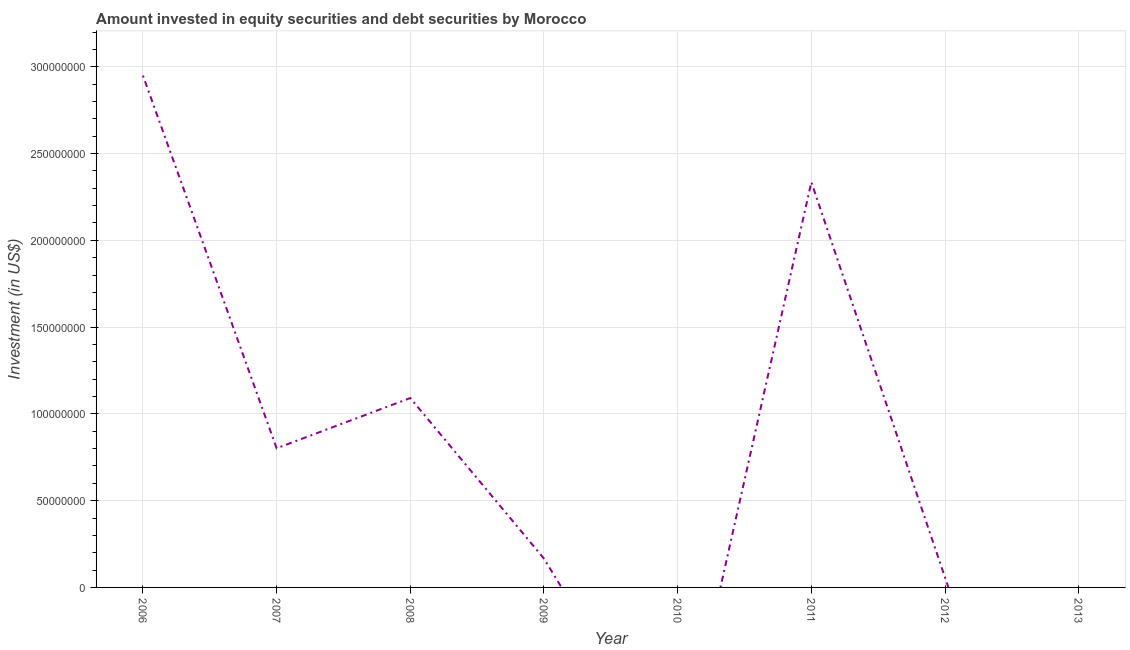What is the portfolio investment in 2008?
Keep it short and to the point. 1.09e+08. Across all years, what is the maximum portfolio investment?
Ensure brevity in your answer.  2.95e+08. Across all years, what is the minimum portfolio investment?
Keep it short and to the point. 0. What is the sum of the portfolio investment?
Make the answer very short. 7.40e+08. What is the difference between the portfolio investment in 2008 and 2009?
Provide a short and direct response. 9.25e+07. What is the average portfolio investment per year?
Keep it short and to the point. 9.25e+07. What is the median portfolio investment?
Keep it short and to the point. 4.84e+07. What is the ratio of the portfolio investment in 2008 to that in 2009?
Your answer should be very brief. 6.58. What is the difference between the highest and the second highest portfolio investment?
Your answer should be compact. 6.14e+07. Is the sum of the portfolio investment in 2008 and 2009 greater than the maximum portfolio investment across all years?
Your response must be concise. No. What is the difference between the highest and the lowest portfolio investment?
Offer a terse response. 2.95e+08. Does the portfolio investment monotonically increase over the years?
Offer a very short reply. No. How many lines are there?
Keep it short and to the point. 1. What is the difference between two consecutive major ticks on the Y-axis?
Give a very brief answer. 5.00e+07. Are the values on the major ticks of Y-axis written in scientific E-notation?
Your answer should be compact. No. Does the graph contain grids?
Provide a short and direct response. Yes. What is the title of the graph?
Ensure brevity in your answer.  Amount invested in equity securities and debt securities by Morocco. What is the label or title of the X-axis?
Provide a short and direct response. Year. What is the label or title of the Y-axis?
Your answer should be compact. Investment (in US$). What is the Investment (in US$) of 2006?
Provide a short and direct response. 2.95e+08. What is the Investment (in US$) of 2007?
Make the answer very short. 8.02e+07. What is the Investment (in US$) in 2008?
Give a very brief answer. 1.09e+08. What is the Investment (in US$) of 2009?
Offer a very short reply. 1.66e+07. What is the Investment (in US$) in 2010?
Provide a short and direct response. 0. What is the Investment (in US$) in 2011?
Provide a short and direct response. 2.34e+08. What is the Investment (in US$) in 2012?
Your response must be concise. 5.72e+06. What is the difference between the Investment (in US$) in 2006 and 2007?
Provide a succinct answer. 2.15e+08. What is the difference between the Investment (in US$) in 2006 and 2008?
Keep it short and to the point. 1.86e+08. What is the difference between the Investment (in US$) in 2006 and 2009?
Your response must be concise. 2.78e+08. What is the difference between the Investment (in US$) in 2006 and 2011?
Provide a short and direct response. 6.14e+07. What is the difference between the Investment (in US$) in 2006 and 2012?
Keep it short and to the point. 2.89e+08. What is the difference between the Investment (in US$) in 2007 and 2008?
Offer a terse response. -2.90e+07. What is the difference between the Investment (in US$) in 2007 and 2009?
Provide a succinct answer. 6.36e+07. What is the difference between the Investment (in US$) in 2007 and 2011?
Ensure brevity in your answer.  -1.53e+08. What is the difference between the Investment (in US$) in 2007 and 2012?
Your answer should be compact. 7.44e+07. What is the difference between the Investment (in US$) in 2008 and 2009?
Give a very brief answer. 9.25e+07. What is the difference between the Investment (in US$) in 2008 and 2011?
Provide a short and direct response. -1.24e+08. What is the difference between the Investment (in US$) in 2008 and 2012?
Your response must be concise. 1.03e+08. What is the difference between the Investment (in US$) in 2009 and 2011?
Ensure brevity in your answer.  -2.17e+08. What is the difference between the Investment (in US$) in 2009 and 2012?
Give a very brief answer. 1.09e+07. What is the difference between the Investment (in US$) in 2011 and 2012?
Ensure brevity in your answer.  2.28e+08. What is the ratio of the Investment (in US$) in 2006 to that in 2007?
Offer a terse response. 3.68. What is the ratio of the Investment (in US$) in 2006 to that in 2008?
Your response must be concise. 2.7. What is the ratio of the Investment (in US$) in 2006 to that in 2009?
Your response must be concise. 17.77. What is the ratio of the Investment (in US$) in 2006 to that in 2011?
Ensure brevity in your answer.  1.26. What is the ratio of the Investment (in US$) in 2006 to that in 2012?
Offer a very short reply. 51.51. What is the ratio of the Investment (in US$) in 2007 to that in 2008?
Your answer should be compact. 0.73. What is the ratio of the Investment (in US$) in 2007 to that in 2009?
Your answer should be compact. 4.83. What is the ratio of the Investment (in US$) in 2007 to that in 2011?
Your answer should be compact. 0.34. What is the ratio of the Investment (in US$) in 2007 to that in 2012?
Your response must be concise. 14.01. What is the ratio of the Investment (in US$) in 2008 to that in 2009?
Keep it short and to the point. 6.58. What is the ratio of the Investment (in US$) in 2008 to that in 2011?
Your answer should be very brief. 0.47. What is the ratio of the Investment (in US$) in 2008 to that in 2012?
Your answer should be very brief. 19.06. What is the ratio of the Investment (in US$) in 2009 to that in 2011?
Your response must be concise. 0.07. What is the ratio of the Investment (in US$) in 2009 to that in 2012?
Provide a succinct answer. 2.9. What is the ratio of the Investment (in US$) in 2011 to that in 2012?
Offer a very short reply. 40.79. 